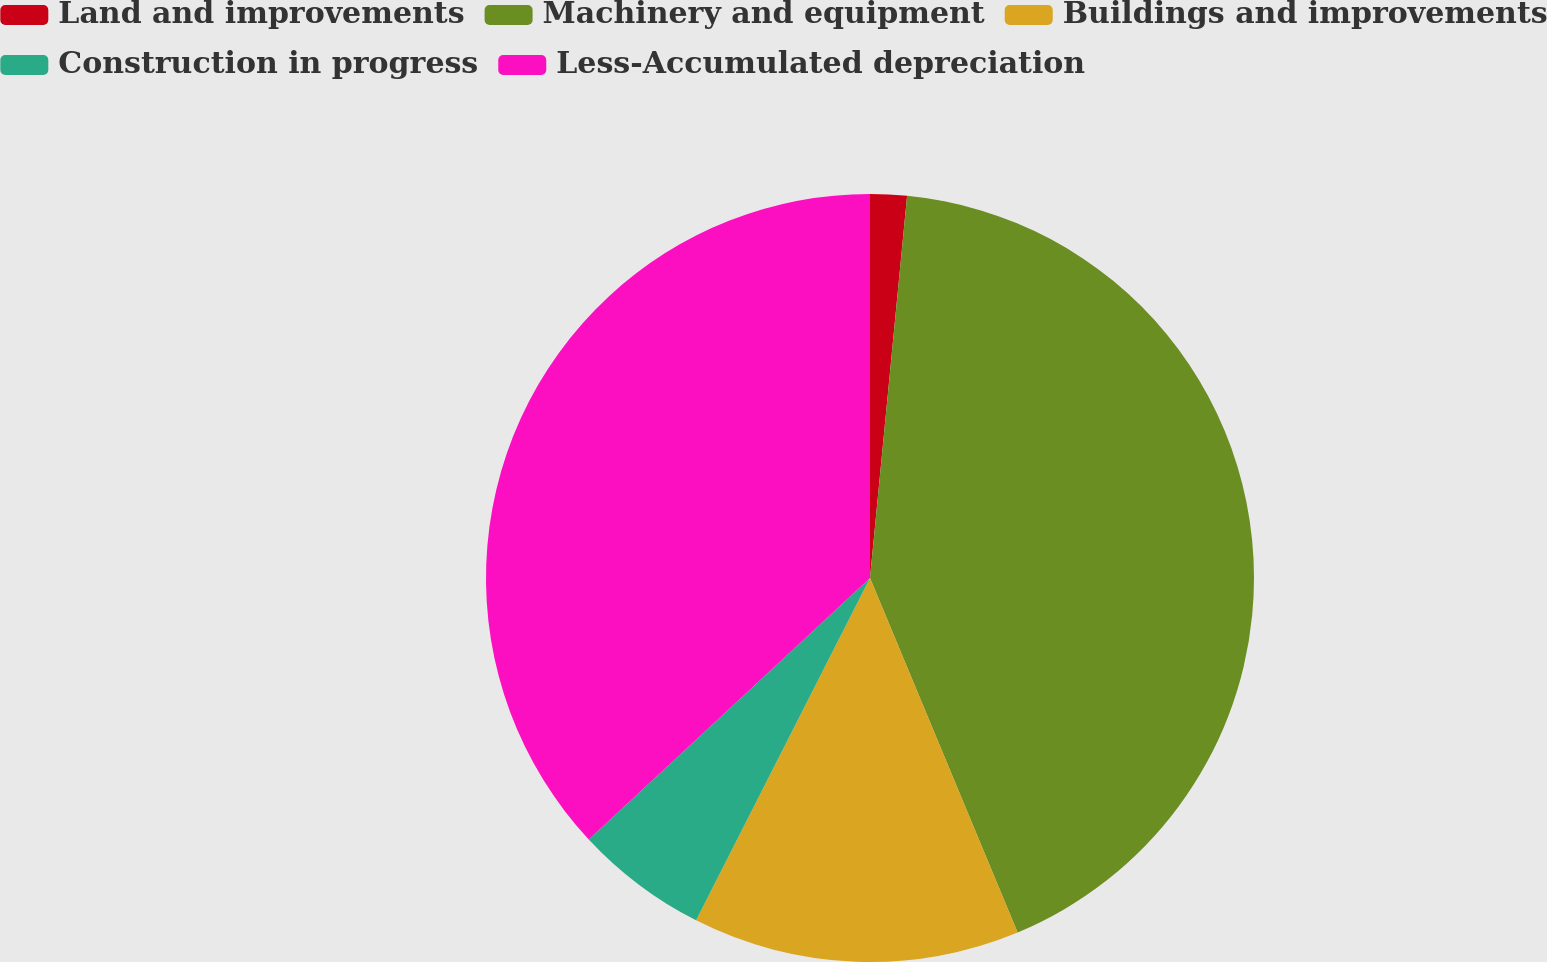Convert chart. <chart><loc_0><loc_0><loc_500><loc_500><pie_chart><fcel>Land and improvements<fcel>Machinery and equipment<fcel>Buildings and improvements<fcel>Construction in progress<fcel>Less-Accumulated depreciation<nl><fcel>1.54%<fcel>42.18%<fcel>13.76%<fcel>5.6%<fcel>36.92%<nl></chart> 